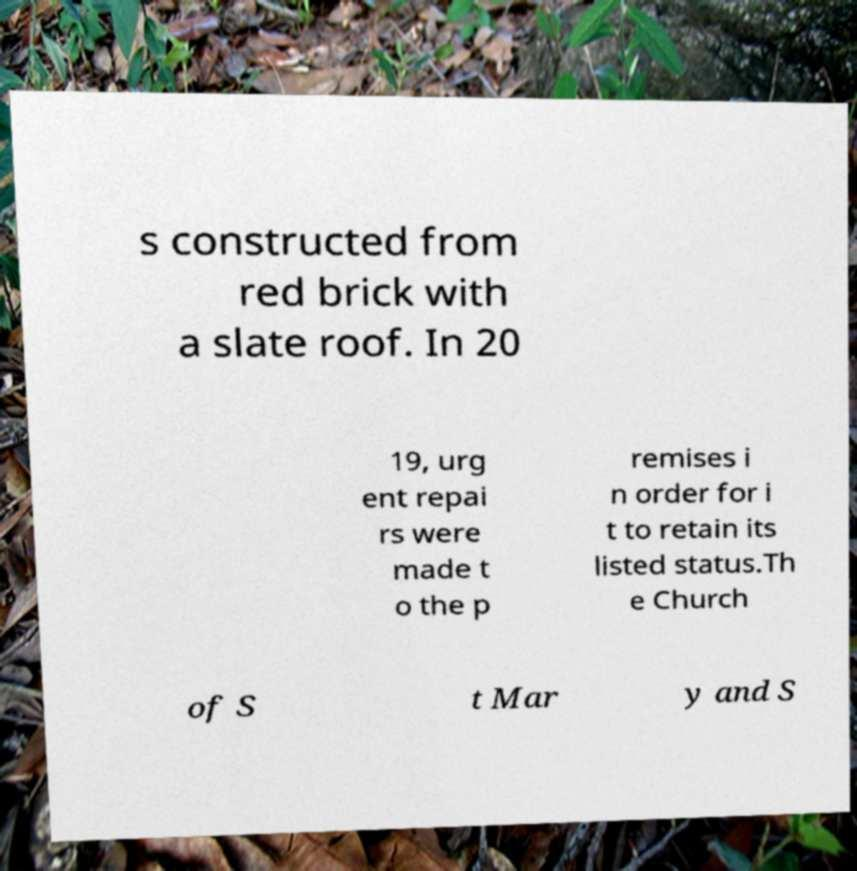There's text embedded in this image that I need extracted. Can you transcribe it verbatim? s constructed from red brick with a slate roof. In 20 19, urg ent repai rs were made t o the p remises i n order for i t to retain its listed status.Th e Church of S t Mar y and S 